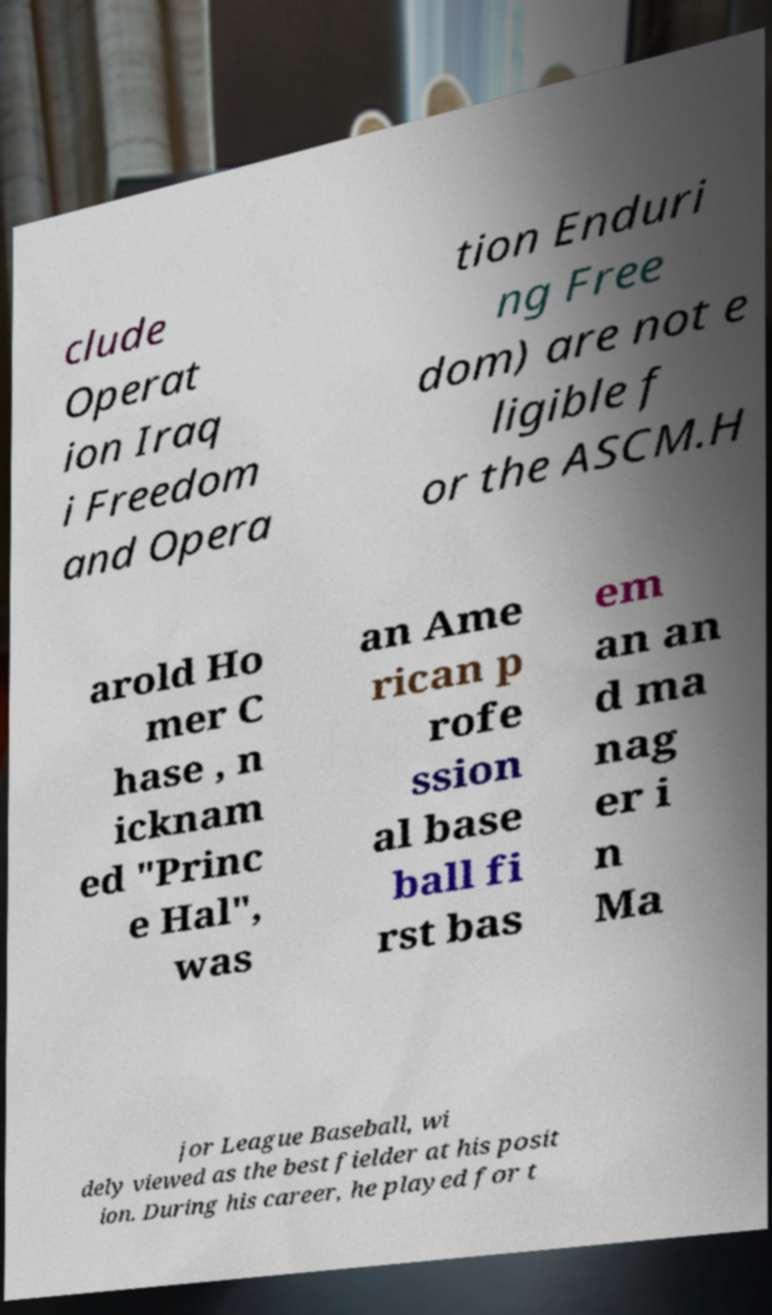Please identify and transcribe the text found in this image. clude Operat ion Iraq i Freedom and Opera tion Enduri ng Free dom) are not e ligible f or the ASCM.H arold Ho mer C hase , n icknam ed "Princ e Hal", was an Ame rican p rofe ssion al base ball fi rst bas em an an d ma nag er i n Ma jor League Baseball, wi dely viewed as the best fielder at his posit ion. During his career, he played for t 